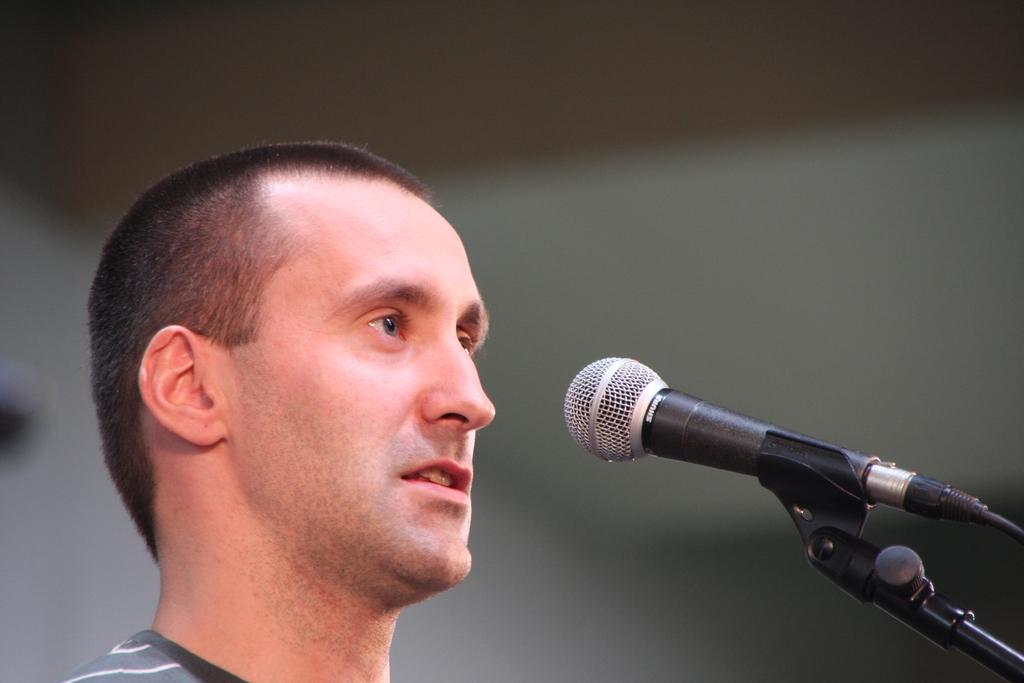Who is present in the image? There is a man in the image. What object is visible in the image? There is a microphone in the image. Can you describe the background of the image? The background of the image is blurred. What type of silk fabric is draped over the man's shoulders in the image? There is no silk fabric present in the image; the man is not wearing any clothing or accessories that resemble silk. 